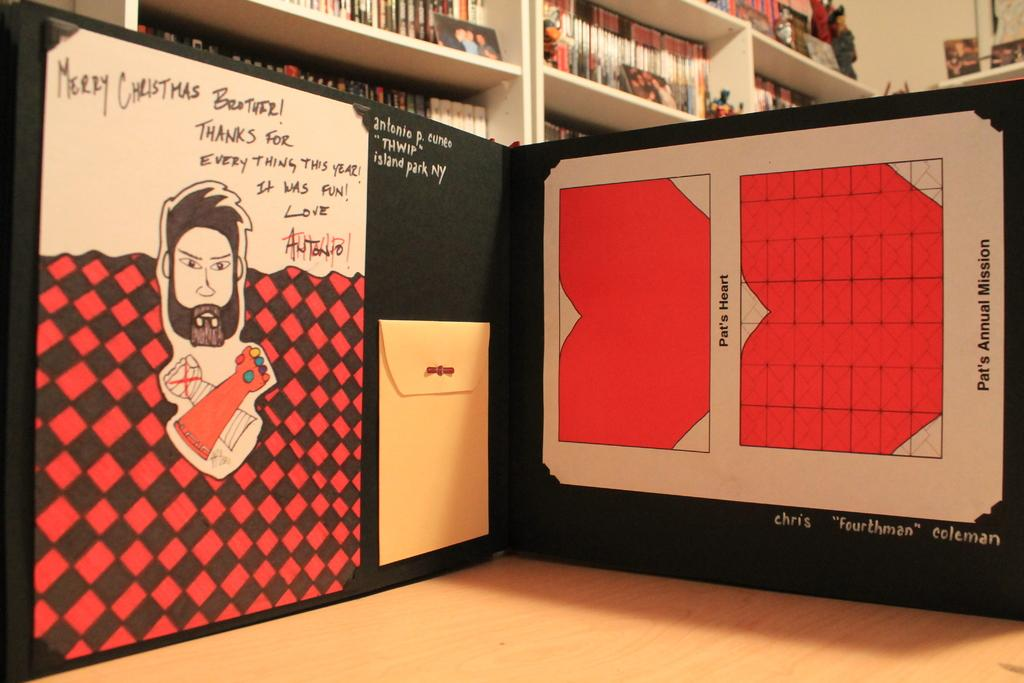<image>
Provide a brief description of the given image. A man with a beard and wearing the Infinity Gauntlet has been drawn on a checkerboard background underneath the words Merry Christmas Brother! 